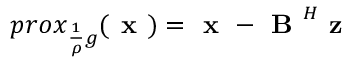Convert formula to latex. <formula><loc_0><loc_0><loc_500><loc_500>p r o x _ { \frac { 1 } { \rho } g } ( x ) = x - B ^ { H } z</formula> 